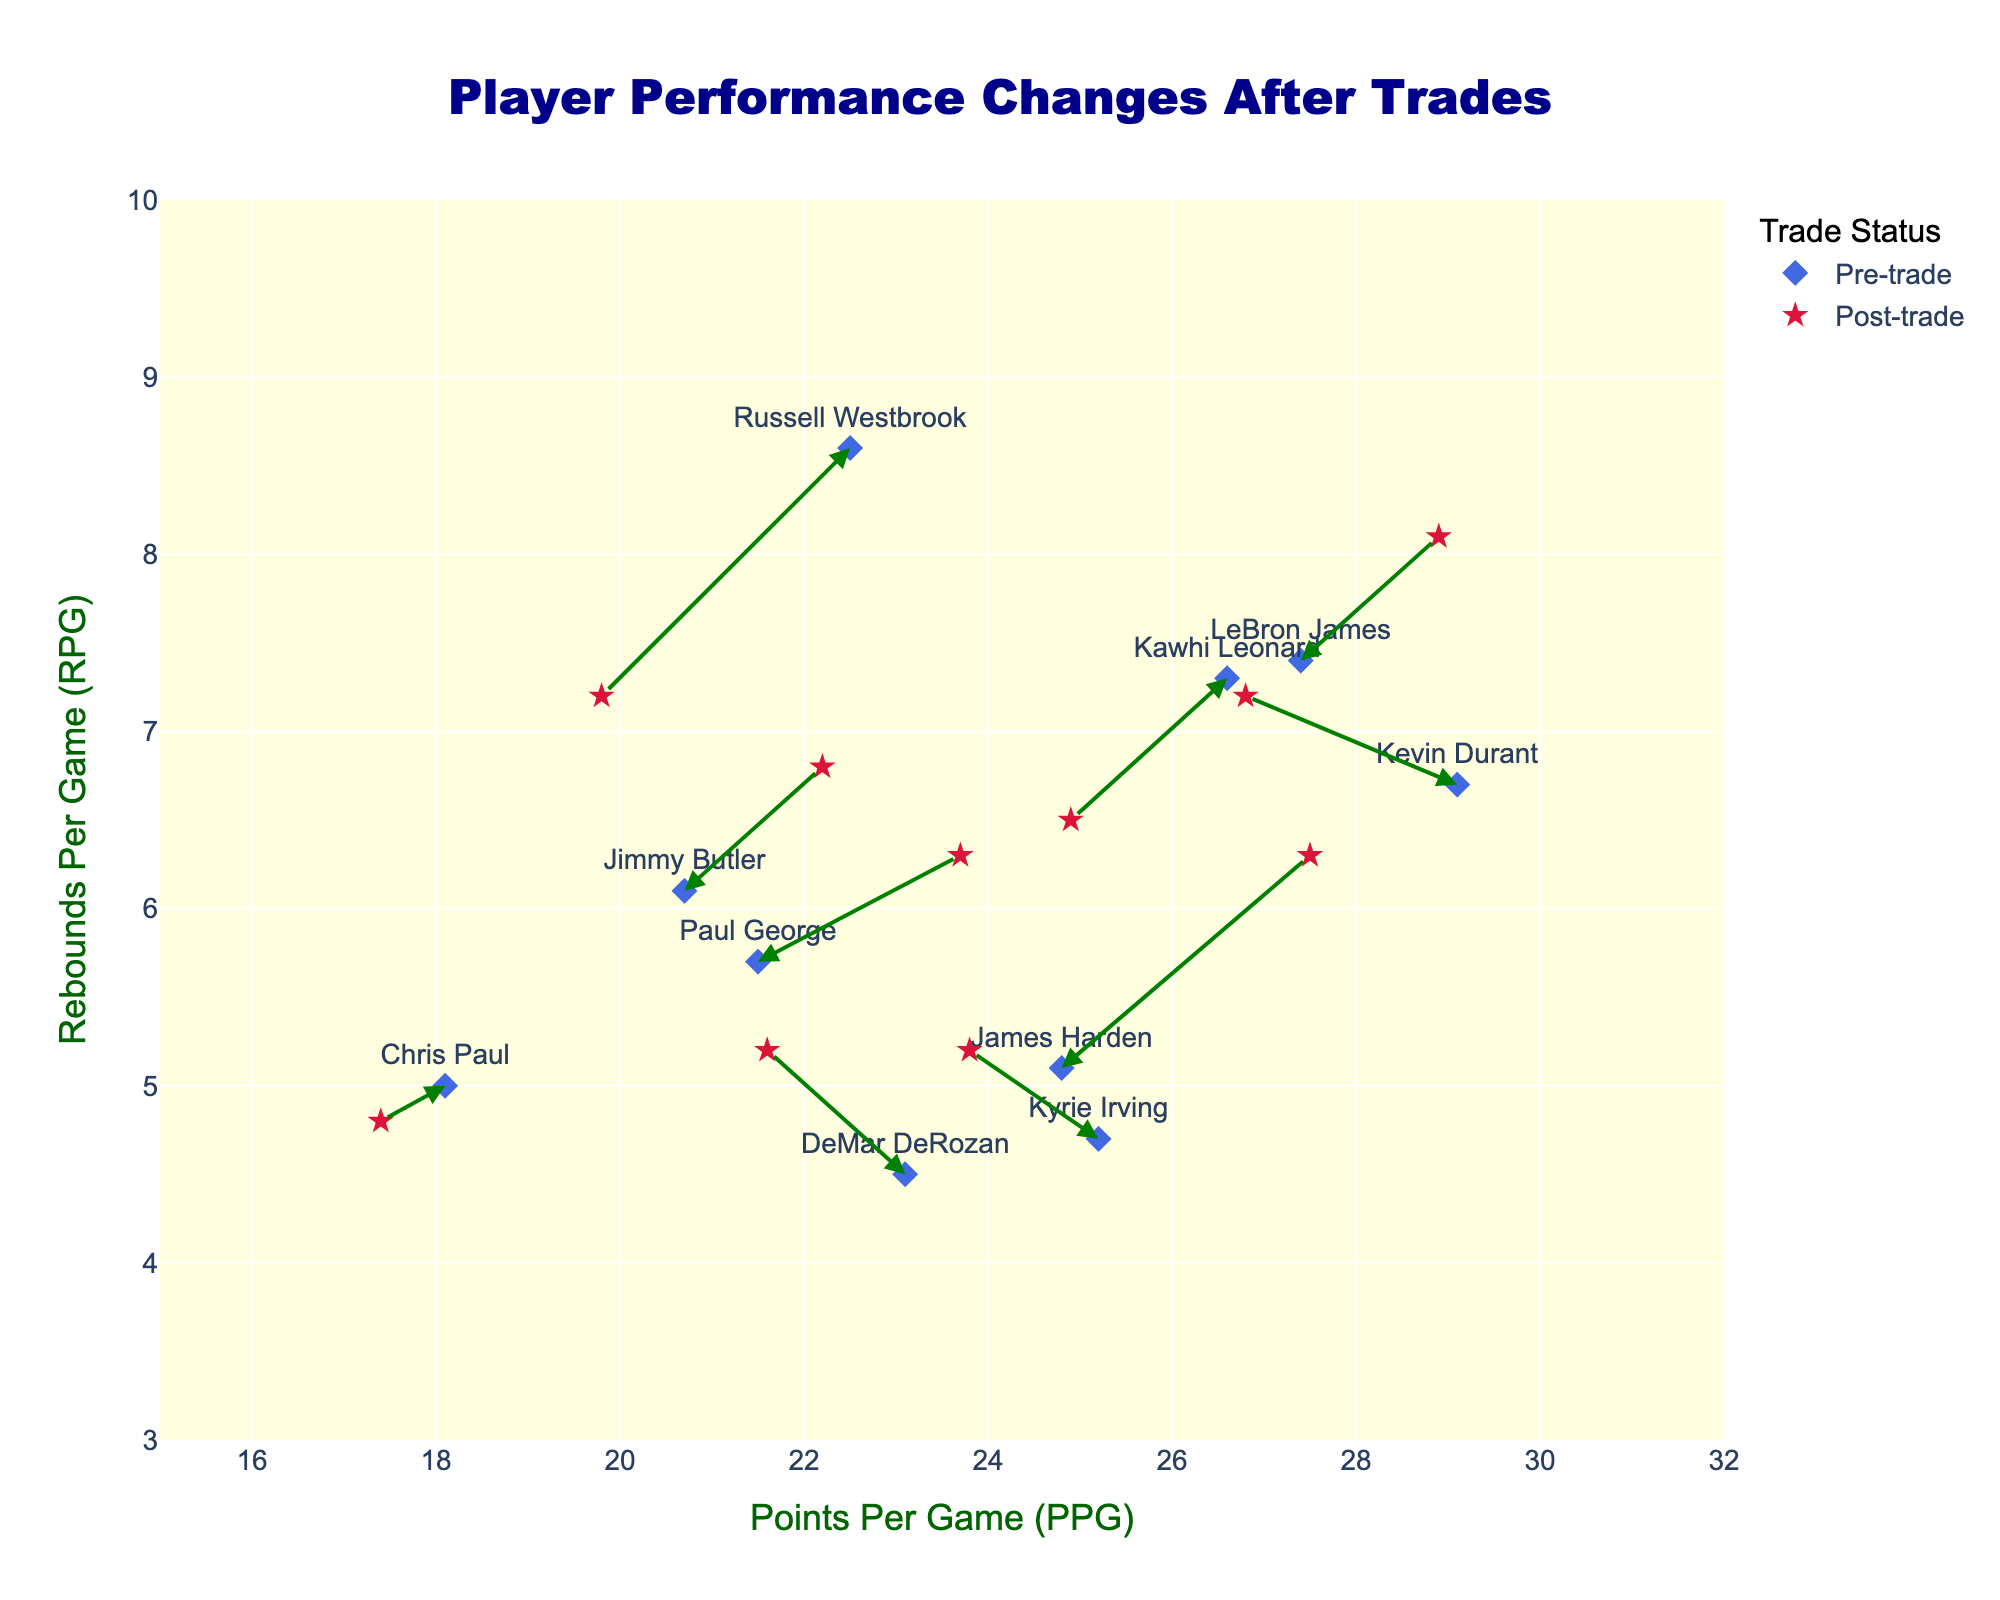What's the title of the figure? The title is usually displayed at the top of the figure. In this case, it indicates the main topic or insight that the plot is intended to convey.
Answer: Player Performance Changes After Trades How many players are represented in the figure? Count the number of different "diamond" markers with player names indicating pre-trade positions in the quiver plot. Each represents a different player.
Answer: 10 What do the colors royal blue and crimson represent in the plot? According to the figure legend, royal blue markers represent player performance statistics before trades, while crimson markers represent performance after trades.
Answer: Royal blue: Pre-trade, Crimson: Post-trade What's the range of the Points Per Game (PPG) on the x-axis? Look at the x-axis and identify the minimum and maximum values indicated. The x-axis range is usually set to cover the minimum and maximum values of the data points.
Answer: 15 to 32 Which player had the highest increase in Points Per Game (PPG) after the trade? Identify the player with the longest arrow pointing to the right, representing a significant increase in PPG.
Answer: James Harden How many players experienced a decrease in Points Per Game (PPG) after the trade? Count the number of arrows that point to the left, indicating a decrease in PPG.
Answer: 5 Who experienced the biggest decline in Rebounds Per Game (RPG) after the trade? Find the player whose arrows have the steepest downward gradient, indicating a significant decrease in RPG.
Answer: Kawhi Leonard Which player experienced an increase in both PPG and RPG after the trade? Look for an arrow pointing diagonally to the upper right, indicating increases in both metrics.
Answer: Jimmy Butler Compare the pre-trade and post-trade RPG for Kevin Durant. Did his performance in this metric improve or decline? Examine the position of Kevin Durant's markers and arrows in the Y-dimension (RPG). Compare the pre-trade (royal blue) and post-trade (crimson) values.
Answer: Improve Identify the outliers where performance drastically changed post-trade in either PPG or RPG. Who are the players? Locate the arrows with steepest slopes or the longest lengths, indicating significant performance changes.
Answer: James Harden (PPG), LeBron James (RPG) 